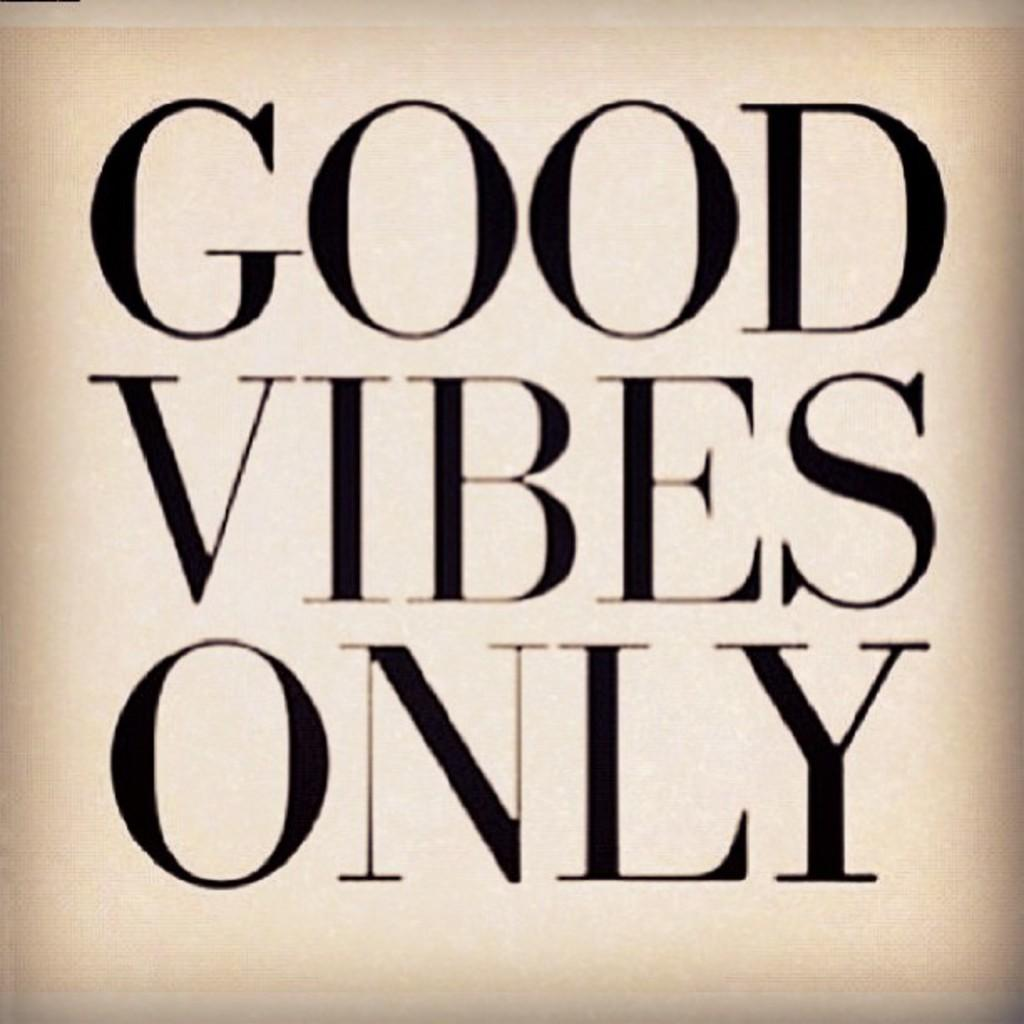<image>
Offer a succinct explanation of the picture presented. Words that say Good Vibes Only in black with a tan background. 